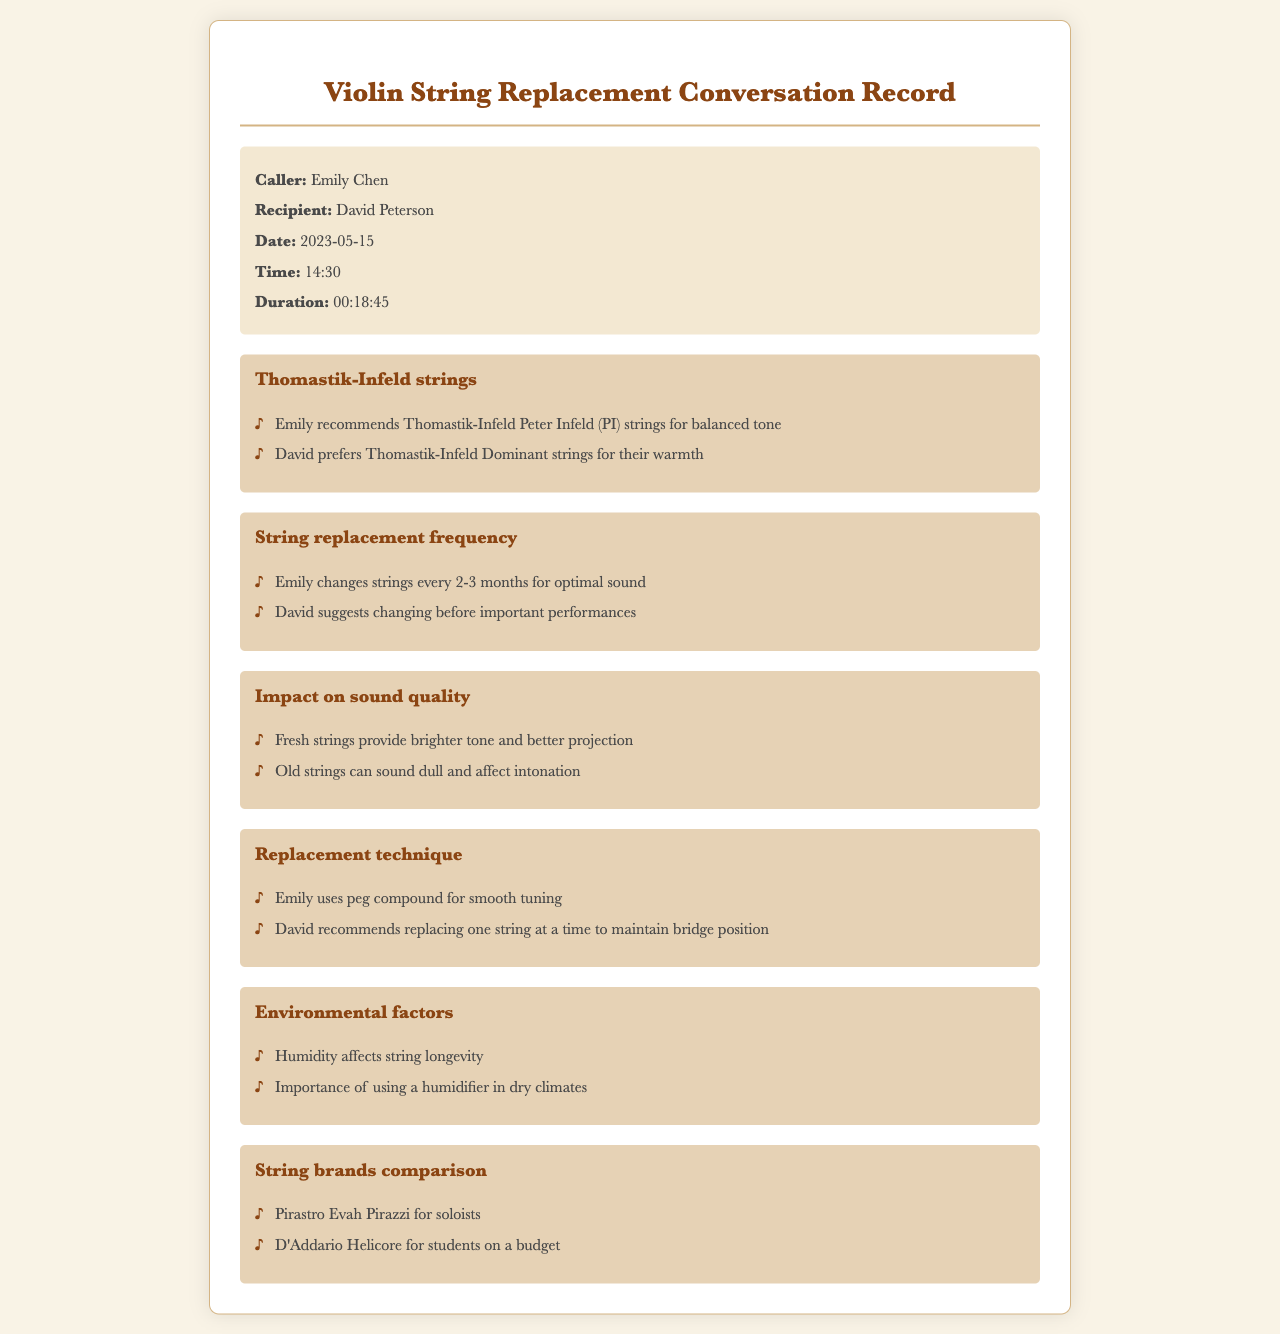What is the call date? The call date is mentioned in the call details section of the document, which states it is May 15, 2023.
Answer: May 15, 2023 Who prefers Thomastik-Infeld Dominant strings? The preference for Thomastik-Infeld Dominant strings is noted in the conversation, specifically mentioned by David Peterson.
Answer: David Peterson How often does Emily change her strings? The frequency of string changes is discussed by Emily, who mentions changing them every 2-3 months for optimal sound.
Answer: Every 2-3 months What does David recommend for maintaining bridge position during string replacement? The document indicates David's recommendation is to replace one string at a time to maintain bridge position.
Answer: One string at a time What is the main impact of fresh strings on sound quality? The document states that fresh strings provide a brighter tone and better projection, emphasizing their positive impact on the sound.
Answer: Brighter tone and better projection Which string brand is suggested for students on a budget? The comparison of string brands includes a mention of D'Addario Helicore as a suitable option for budget-conscious students.
Answer: D'Addario Helicore What technique does Emily use for tuning? In the replacement technique section, it is noted that Emily uses peg compound for smooth tuning.
Answer: Peg compound What environmental factor affects string longevity? Environmental factors mentioned include humidity, which is discussed in relation to string longevity.
Answer: Humidity 